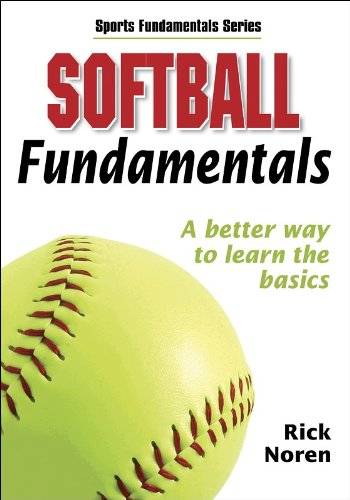What is the title of this book? The title of this book is 'Softball Fundamentals (Sports Fundamentals)', a comprehensive guide designed for those interested in learning the basic techniques and rules of softball. 